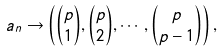Convert formula to latex. <formula><loc_0><loc_0><loc_500><loc_500>a _ { n } \to \left ( { \binom { p } { 1 } , \binom { p } { 2 } , \cdots , \binom { p } { p - 1 } } \right ) ,</formula> 